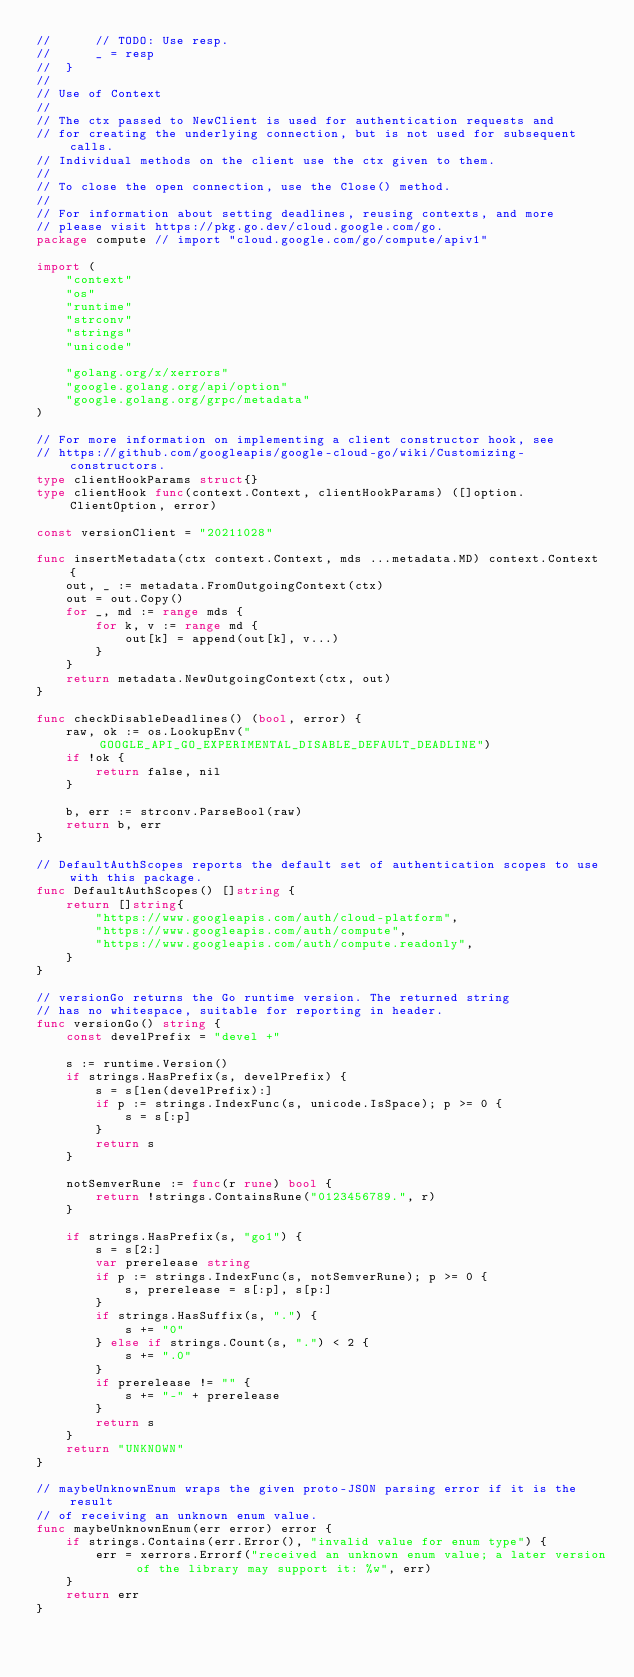Convert code to text. <code><loc_0><loc_0><loc_500><loc_500><_Go_>//  	// TODO: Use resp.
//  	_ = resp
//  }
//
// Use of Context
//
// The ctx passed to NewClient is used for authentication requests and
// for creating the underlying connection, but is not used for subsequent calls.
// Individual methods on the client use the ctx given to them.
//
// To close the open connection, use the Close() method.
//
// For information about setting deadlines, reusing contexts, and more
// please visit https://pkg.go.dev/cloud.google.com/go.
package compute // import "cloud.google.com/go/compute/apiv1"

import (
	"context"
	"os"
	"runtime"
	"strconv"
	"strings"
	"unicode"

	"golang.org/x/xerrors"
	"google.golang.org/api/option"
	"google.golang.org/grpc/metadata"
)

// For more information on implementing a client constructor hook, see
// https://github.com/googleapis/google-cloud-go/wiki/Customizing-constructors.
type clientHookParams struct{}
type clientHook func(context.Context, clientHookParams) ([]option.ClientOption, error)

const versionClient = "20211028"

func insertMetadata(ctx context.Context, mds ...metadata.MD) context.Context {
	out, _ := metadata.FromOutgoingContext(ctx)
	out = out.Copy()
	for _, md := range mds {
		for k, v := range md {
			out[k] = append(out[k], v...)
		}
	}
	return metadata.NewOutgoingContext(ctx, out)
}

func checkDisableDeadlines() (bool, error) {
	raw, ok := os.LookupEnv("GOOGLE_API_GO_EXPERIMENTAL_DISABLE_DEFAULT_DEADLINE")
	if !ok {
		return false, nil
	}

	b, err := strconv.ParseBool(raw)
	return b, err
}

// DefaultAuthScopes reports the default set of authentication scopes to use with this package.
func DefaultAuthScopes() []string {
	return []string{
		"https://www.googleapis.com/auth/cloud-platform",
		"https://www.googleapis.com/auth/compute",
		"https://www.googleapis.com/auth/compute.readonly",
	}
}

// versionGo returns the Go runtime version. The returned string
// has no whitespace, suitable for reporting in header.
func versionGo() string {
	const develPrefix = "devel +"

	s := runtime.Version()
	if strings.HasPrefix(s, develPrefix) {
		s = s[len(develPrefix):]
		if p := strings.IndexFunc(s, unicode.IsSpace); p >= 0 {
			s = s[:p]
		}
		return s
	}

	notSemverRune := func(r rune) bool {
		return !strings.ContainsRune("0123456789.", r)
	}

	if strings.HasPrefix(s, "go1") {
		s = s[2:]
		var prerelease string
		if p := strings.IndexFunc(s, notSemverRune); p >= 0 {
			s, prerelease = s[:p], s[p:]
		}
		if strings.HasSuffix(s, ".") {
			s += "0"
		} else if strings.Count(s, ".") < 2 {
			s += ".0"
		}
		if prerelease != "" {
			s += "-" + prerelease
		}
		return s
	}
	return "UNKNOWN"
}

// maybeUnknownEnum wraps the given proto-JSON parsing error if it is the result
// of receiving an unknown enum value.
func maybeUnknownEnum(err error) error {
	if strings.Contains(err.Error(), "invalid value for enum type") {
		err = xerrors.Errorf("received an unknown enum value; a later version of the library may support it: %w", err)
	}
	return err
}
</code> 